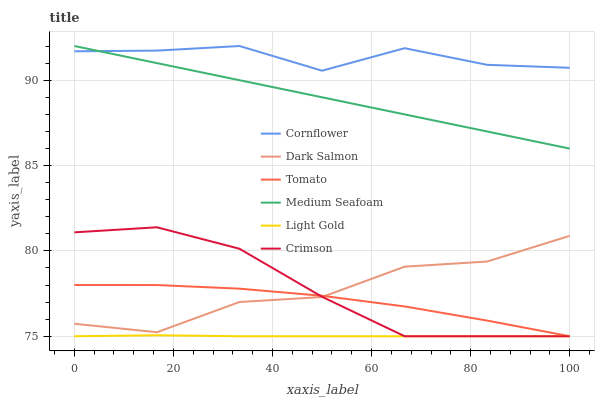Does Light Gold have the minimum area under the curve?
Answer yes or no. Yes. Does Cornflower have the maximum area under the curve?
Answer yes or no. Yes. Does Dark Salmon have the minimum area under the curve?
Answer yes or no. No. Does Dark Salmon have the maximum area under the curve?
Answer yes or no. No. Is Medium Seafoam the smoothest?
Answer yes or no. Yes. Is Dark Salmon the roughest?
Answer yes or no. Yes. Is Cornflower the smoothest?
Answer yes or no. No. Is Cornflower the roughest?
Answer yes or no. No. Does Tomato have the lowest value?
Answer yes or no. Yes. Does Dark Salmon have the lowest value?
Answer yes or no. No. Does Medium Seafoam have the highest value?
Answer yes or no. Yes. Does Dark Salmon have the highest value?
Answer yes or no. No. Is Dark Salmon less than Cornflower?
Answer yes or no. Yes. Is Cornflower greater than Tomato?
Answer yes or no. Yes. Does Tomato intersect Crimson?
Answer yes or no. Yes. Is Tomato less than Crimson?
Answer yes or no. No. Is Tomato greater than Crimson?
Answer yes or no. No. Does Dark Salmon intersect Cornflower?
Answer yes or no. No. 